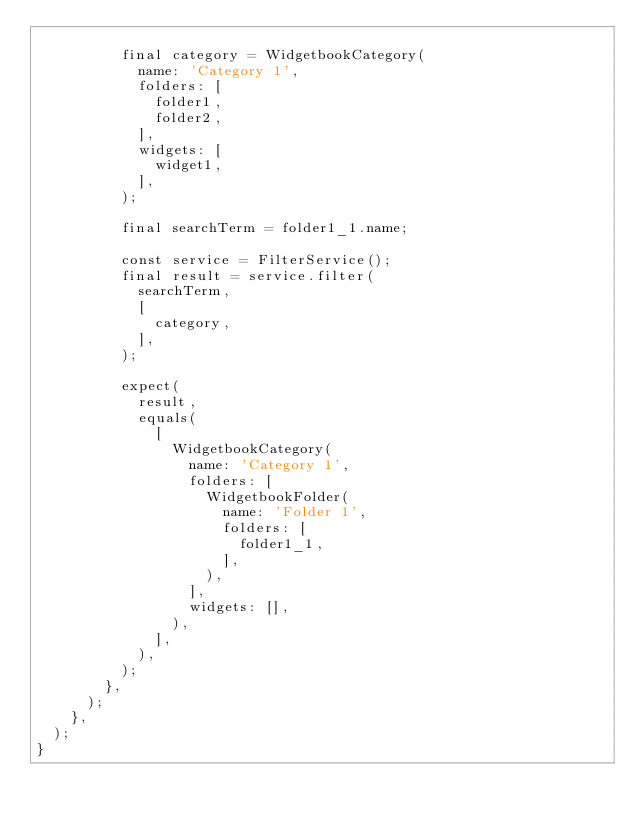Convert code to text. <code><loc_0><loc_0><loc_500><loc_500><_Dart_>
          final category = WidgetbookCategory(
            name: 'Category 1',
            folders: [
              folder1,
              folder2,
            ],
            widgets: [
              widget1,
            ],
          );

          final searchTerm = folder1_1.name;

          const service = FilterService();
          final result = service.filter(
            searchTerm,
            [
              category,
            ],
          );

          expect(
            result,
            equals(
              [
                WidgetbookCategory(
                  name: 'Category 1',
                  folders: [
                    WidgetbookFolder(
                      name: 'Folder 1',
                      folders: [
                        folder1_1,
                      ],
                    ),
                  ],
                  widgets: [],
                ),
              ],
            ),
          );
        },
      );
    },
  );
}
</code> 